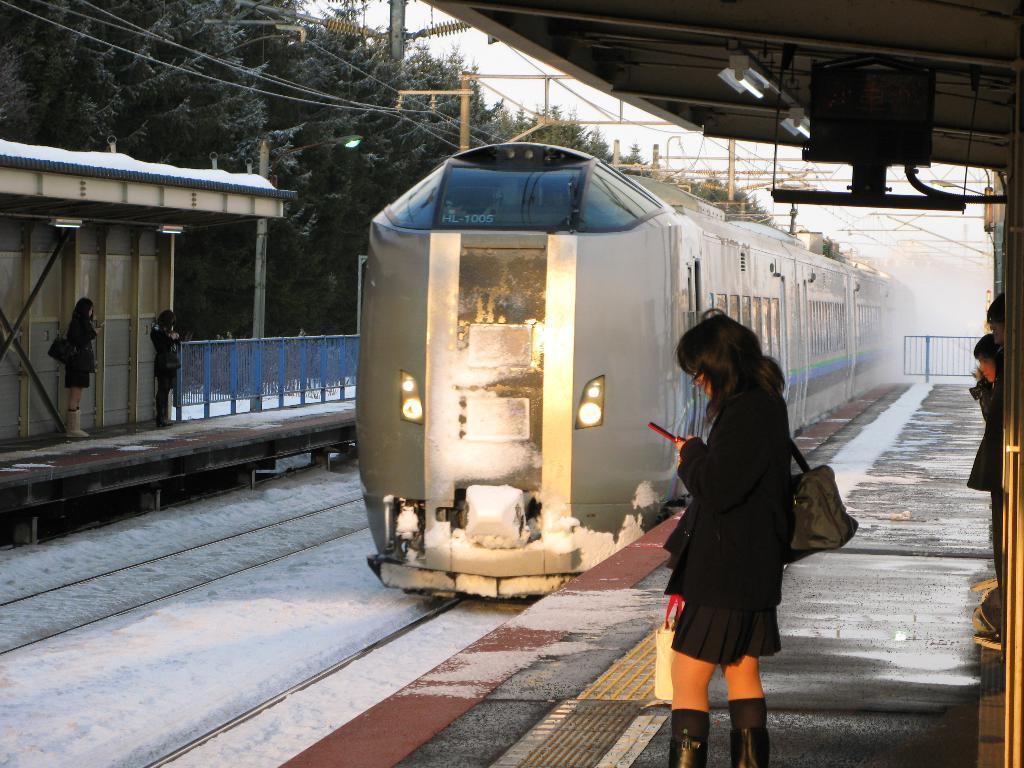How would you summarize this image in a sentence or two? In this image we can see these people are standing on the platform. Here we can see the snow covered on the railway tracks and a train is moving on the railway track. Here we can see lights to the ceiling, we can see wires, trees, barriers, poles and sky in the background. 